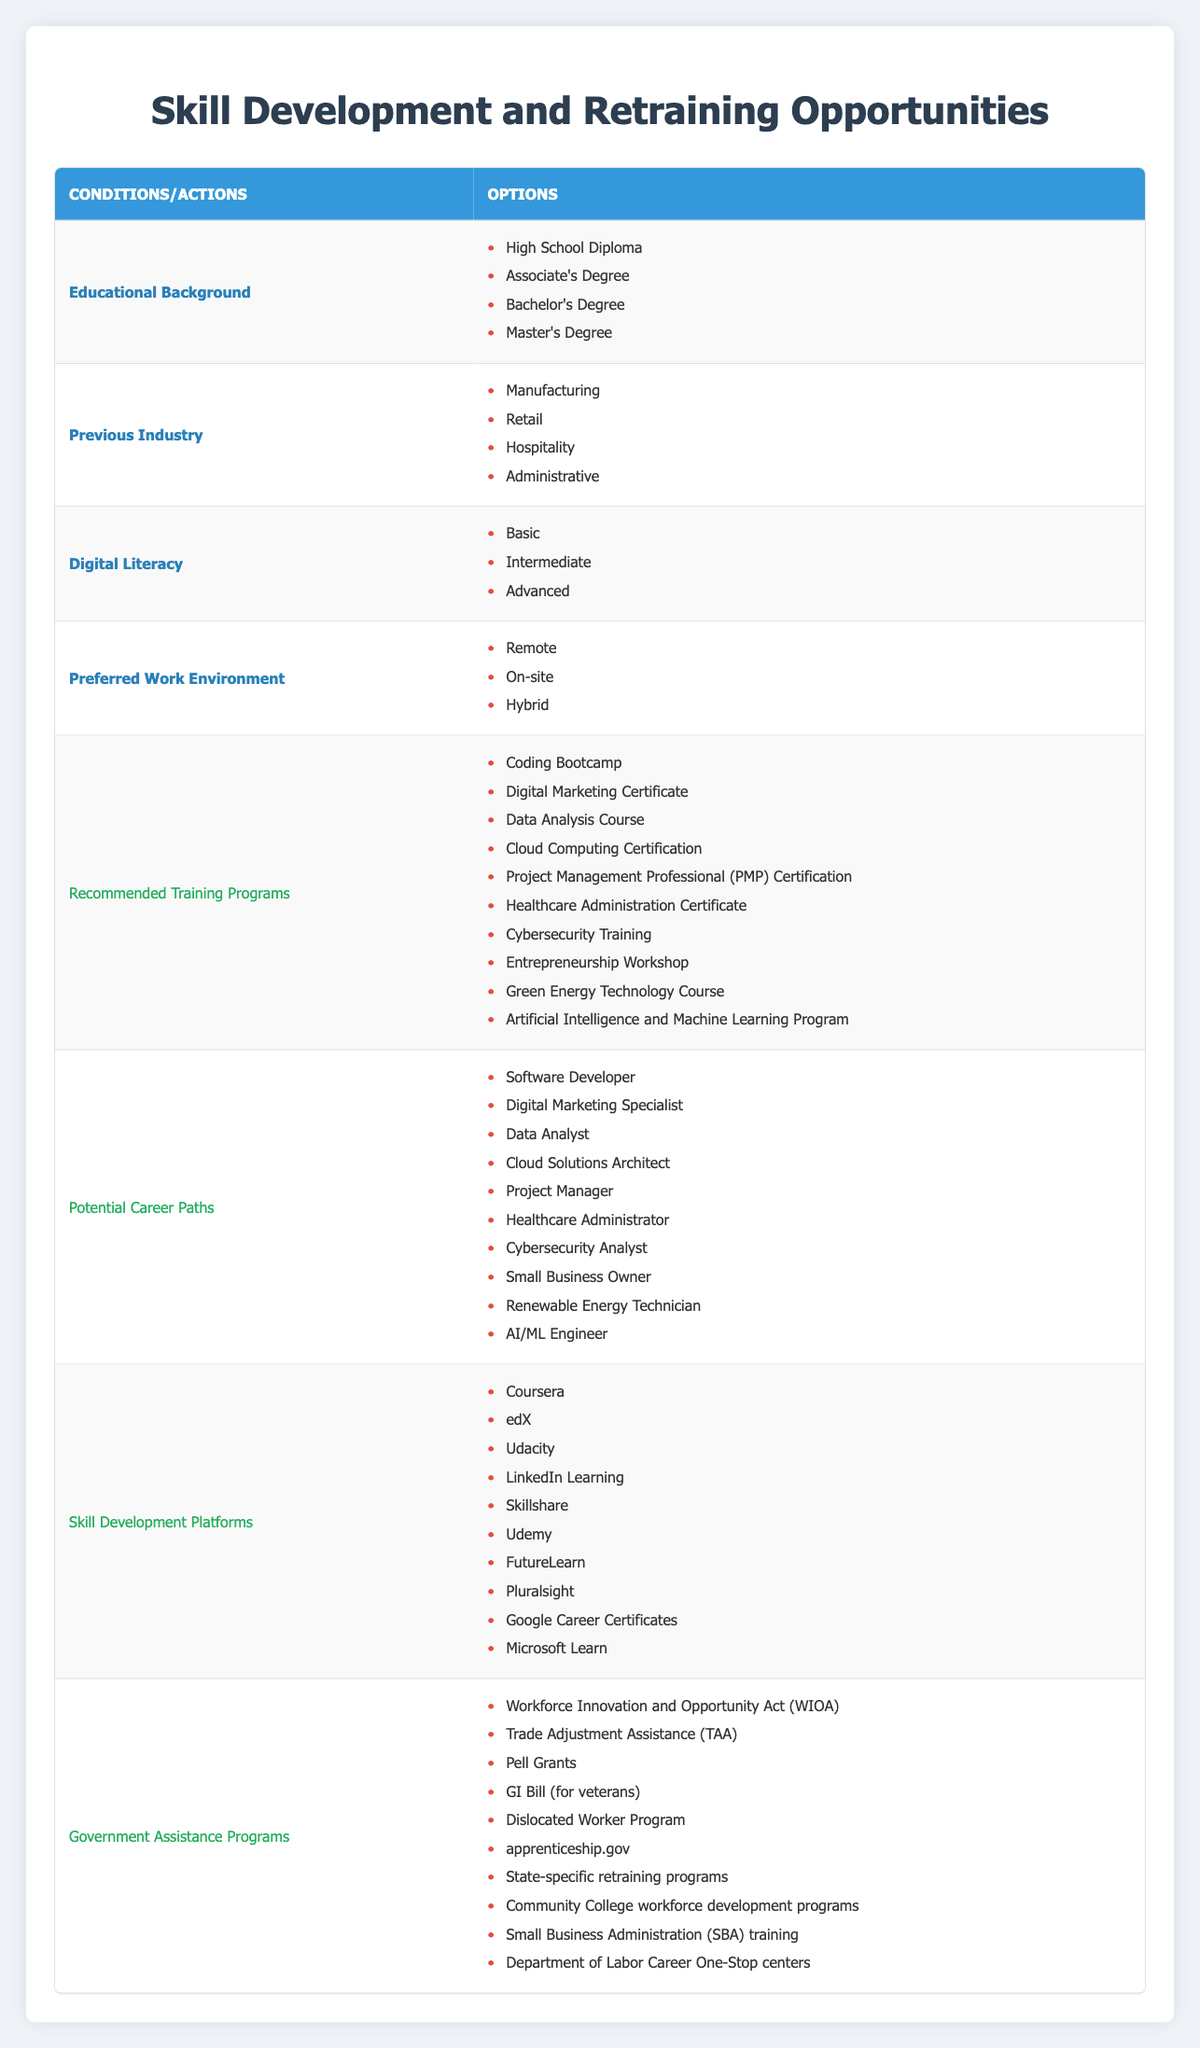What are the recommended training programs for someone with a Bachelor's Degree? According to the table, the recommended training programs are listed under the actions. Since the query is specifically about a Bachelor's Degree, one can infer that all training programs are available options regardless of education level. Therefore, the options are: Coding Bootcamp, Digital Marketing Certificate, Data Analysis Course, Cloud Computing Certification, Project Management Professional Certification, Healthcare Administration Certificate, Cybersecurity Training, Entrepreneurship Workshop, Green Energy Technology Course, and Artificial Intelligence and Machine Learning Program.
Answer: All listed programs Which potential career path aligns with training in Digital Marketing? Referring to the actions in the table, Digital Marketing aligns with the potential career path of Digital Marketing Specialist. Hence, seeking training in this area should target that specific career path.
Answer: Digital Marketing Specialist Is it true that someone with a Master’s Degree can pursue a career as a Cybersecurity Analyst? The table includes Cybersecurity Analyst as a potential career path, which is available to anyone regardless of educational background. A person with a Master’s Degree can certainly pursue this career, making this statement true.
Answer: Yes How many skill development platforms are listed in the table? The table lists ten different skill development platforms under the actions. By counting each one (Coursera, edX, Udacity, LinkedIn Learning, Skillshare, Udemy, FutureLearn, Pluralsight, Google Career Certificates, Microsoft Learn), we can determine the total.
Answer: 10 What training program is suggested for someone coming from a Manufacturing background with Basic Digital Literacy? While the table does not specify training programs based on previous industry or digital literacy, reviewing the full list can help identify applicable programs. Programs like Cybersecurity Training or a Coding Bootcamp may be suitable for anyone seeking to upgrade skills and move into new industries, especially given the high demand in those fields. Therefore, any of these programs could be recommended.
Answer: Cybersecurity Training or Coding Bootcamp Are there government assistance programs available for skill development? Yes, the table lists several government assistance programs under the actions that provide support for skill development, including WIOA, TAA, Pell Grants, and others. Thus, this statement is true.
Answer: Yes What is the relationship between an Associate's Degree holder and potential careers in Cloud Computing? The potential career tied to training in Cloud Computing would be a Cloud Solutions Architect. This is applicable to individuals with various educational backgrounds, including those with an Associate's Degree, meaning they have valid opportunities in this career path.
Answer: Cloud Solutions Architect Which training program would best suit someone looking to become an AI/ML Engineer? Among the recommended training programs, the Artificial Intelligence and Machine Learning Program would be directly relevant. This specific program is designed for individuals aiming to enter this field, hence it is the best fit.
Answer: Artificial Intelligence and Machine Learning Program 